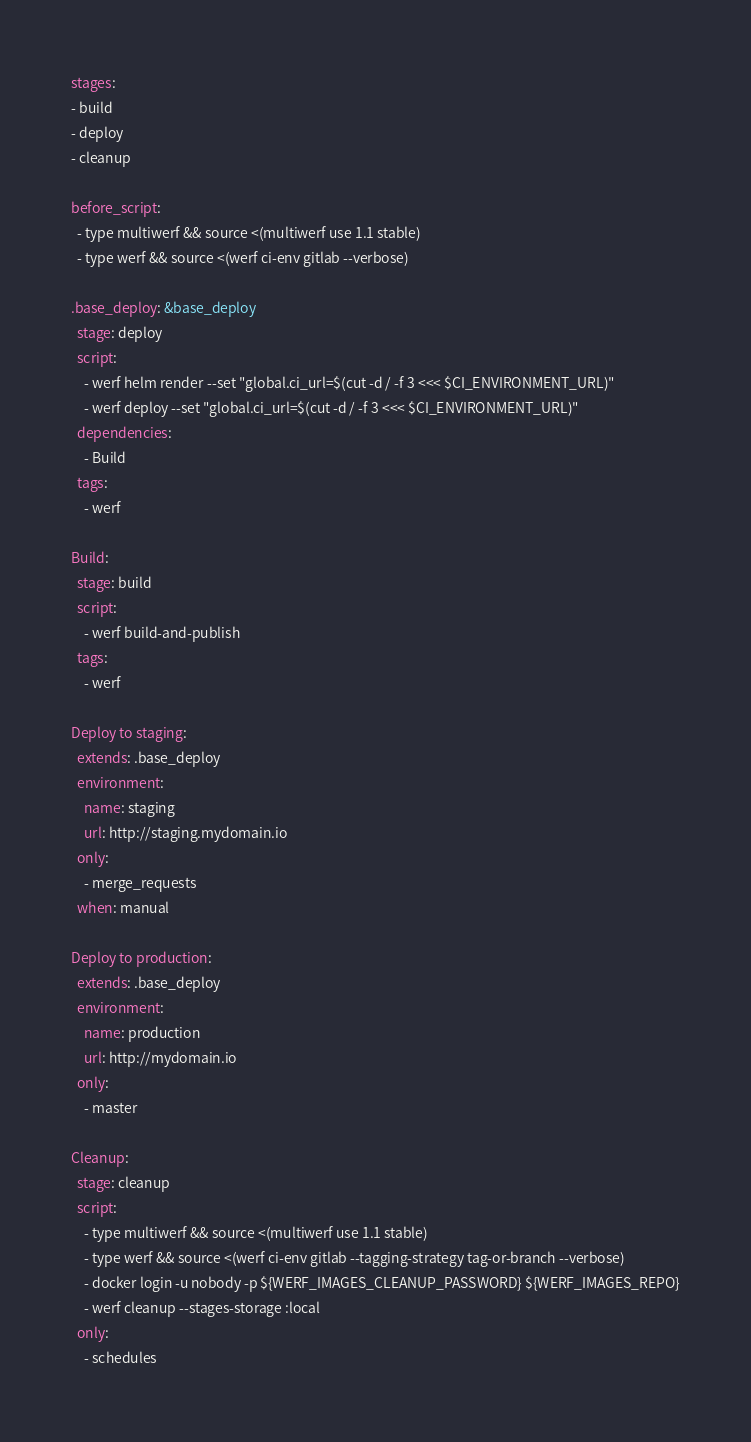<code> <loc_0><loc_0><loc_500><loc_500><_YAML_>stages:
- build
- deploy
- cleanup

before_script:
  - type multiwerf && source <(multiwerf use 1.1 stable)
  - type werf && source <(werf ci-env gitlab --verbose)

.base_deploy: &base_deploy
  stage: deploy
  script:
    - werf helm render --set "global.ci_url=$(cut -d / -f 3 <<< $CI_ENVIRONMENT_URL)"
    - werf deploy --set "global.ci_url=$(cut -d / -f 3 <<< $CI_ENVIRONMENT_URL)"
  dependencies:
    - Build
  tags:
    - werf

Build:
  stage: build
  script:
    - werf build-and-publish
  tags:
    - werf

Deploy to staging:
  extends: .base_deploy
  environment:
    name: staging
    url: http://staging.mydomain.io
  only:
    - merge_requests
  when: manual

Deploy to production:
  extends: .base_deploy
  environment:
    name: production
    url: http://mydomain.io
  only:
    - master

Cleanup:
  stage: cleanup
  script:
    - type multiwerf && source <(multiwerf use 1.1 stable)
    - type werf && source <(werf ci-env gitlab --tagging-strategy tag-or-branch --verbose)
    - docker login -u nobody -p ${WERF_IMAGES_CLEANUP_PASSWORD} ${WERF_IMAGES_REPO}
    - werf cleanup --stages-storage :local
  only:
    - schedules</code> 